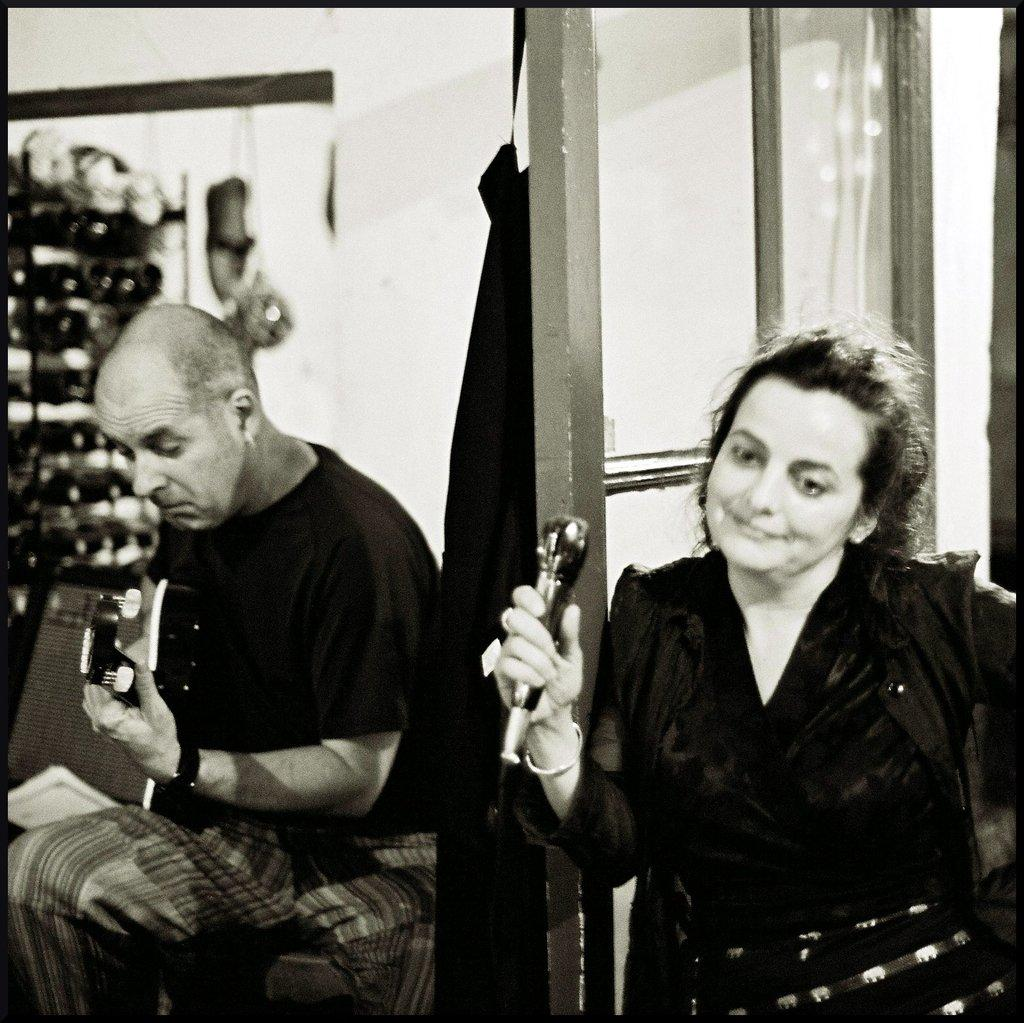How many people are in the image? There are two persons in the image. What are the persons doing in the image? The persons are sitting on chairs and holding microphones. What can be seen in the background of the image? There is a wall, a door, and additional objects visible in the background of the image. What type of branch is hanging from the ceiling in the image? There is no branch hanging from the ceiling in the image. How many balloons are floating in the background of the image? There are no balloons visible in the image. What type of education is being discussed in the image? The image does not depict any discussion about education. 